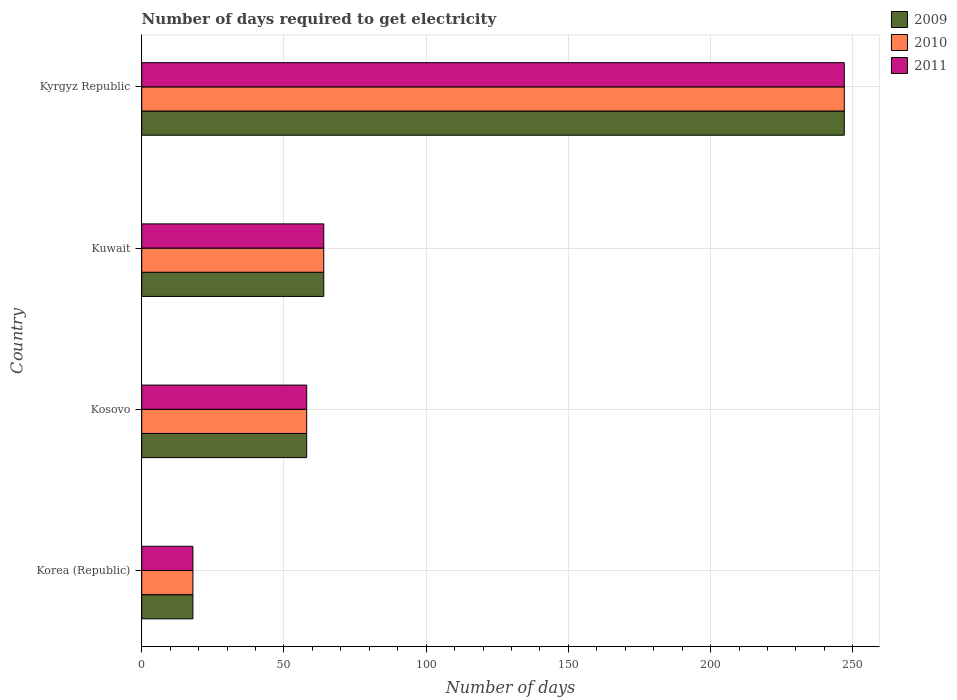Are the number of bars on each tick of the Y-axis equal?
Provide a short and direct response. Yes. How many bars are there on the 2nd tick from the top?
Provide a short and direct response. 3. How many bars are there on the 3rd tick from the bottom?
Offer a terse response. 3. What is the number of days required to get electricity in in 2010 in Kyrgyz Republic?
Offer a terse response. 247. Across all countries, what is the maximum number of days required to get electricity in in 2011?
Make the answer very short. 247. Across all countries, what is the minimum number of days required to get electricity in in 2009?
Keep it short and to the point. 18. In which country was the number of days required to get electricity in in 2009 maximum?
Keep it short and to the point. Kyrgyz Republic. In which country was the number of days required to get electricity in in 2011 minimum?
Keep it short and to the point. Korea (Republic). What is the total number of days required to get electricity in in 2009 in the graph?
Offer a very short reply. 387. What is the difference between the number of days required to get electricity in in 2009 in Korea (Republic) and that in Kyrgyz Republic?
Offer a very short reply. -229. What is the difference between the number of days required to get electricity in in 2010 in Kosovo and the number of days required to get electricity in in 2009 in Kyrgyz Republic?
Provide a short and direct response. -189. What is the average number of days required to get electricity in in 2011 per country?
Provide a short and direct response. 96.75. What is the difference between the number of days required to get electricity in in 2011 and number of days required to get electricity in in 2009 in Korea (Republic)?
Your response must be concise. 0. In how many countries, is the number of days required to get electricity in in 2011 greater than 190 days?
Offer a very short reply. 1. What is the ratio of the number of days required to get electricity in in 2010 in Korea (Republic) to that in Kuwait?
Provide a short and direct response. 0.28. Is the number of days required to get electricity in in 2011 in Kuwait less than that in Kyrgyz Republic?
Offer a very short reply. Yes. What is the difference between the highest and the second highest number of days required to get electricity in in 2010?
Offer a terse response. 183. What is the difference between the highest and the lowest number of days required to get electricity in in 2010?
Your answer should be compact. 229. Is it the case that in every country, the sum of the number of days required to get electricity in in 2011 and number of days required to get electricity in in 2010 is greater than the number of days required to get electricity in in 2009?
Offer a terse response. Yes. How many bars are there?
Your answer should be compact. 12. Are all the bars in the graph horizontal?
Ensure brevity in your answer.  Yes. How many countries are there in the graph?
Provide a short and direct response. 4. Where does the legend appear in the graph?
Ensure brevity in your answer.  Top right. How many legend labels are there?
Provide a succinct answer. 3. How are the legend labels stacked?
Your answer should be compact. Vertical. What is the title of the graph?
Offer a terse response. Number of days required to get electricity. Does "1989" appear as one of the legend labels in the graph?
Offer a very short reply. No. What is the label or title of the X-axis?
Provide a succinct answer. Number of days. What is the label or title of the Y-axis?
Offer a terse response. Country. What is the Number of days of 2009 in Korea (Republic)?
Keep it short and to the point. 18. What is the Number of days of 2011 in Kosovo?
Your answer should be very brief. 58. What is the Number of days in 2009 in Kyrgyz Republic?
Provide a short and direct response. 247. What is the Number of days of 2010 in Kyrgyz Republic?
Keep it short and to the point. 247. What is the Number of days of 2011 in Kyrgyz Republic?
Give a very brief answer. 247. Across all countries, what is the maximum Number of days of 2009?
Make the answer very short. 247. Across all countries, what is the maximum Number of days in 2010?
Provide a succinct answer. 247. Across all countries, what is the maximum Number of days of 2011?
Ensure brevity in your answer.  247. Across all countries, what is the minimum Number of days of 2009?
Your answer should be compact. 18. Across all countries, what is the minimum Number of days in 2010?
Your answer should be very brief. 18. Across all countries, what is the minimum Number of days of 2011?
Keep it short and to the point. 18. What is the total Number of days in 2009 in the graph?
Keep it short and to the point. 387. What is the total Number of days in 2010 in the graph?
Your answer should be compact. 387. What is the total Number of days in 2011 in the graph?
Provide a succinct answer. 387. What is the difference between the Number of days of 2010 in Korea (Republic) and that in Kosovo?
Your response must be concise. -40. What is the difference between the Number of days of 2011 in Korea (Republic) and that in Kosovo?
Your answer should be very brief. -40. What is the difference between the Number of days of 2009 in Korea (Republic) and that in Kuwait?
Make the answer very short. -46. What is the difference between the Number of days of 2010 in Korea (Republic) and that in Kuwait?
Your response must be concise. -46. What is the difference between the Number of days in 2011 in Korea (Republic) and that in Kuwait?
Provide a succinct answer. -46. What is the difference between the Number of days in 2009 in Korea (Republic) and that in Kyrgyz Republic?
Your answer should be very brief. -229. What is the difference between the Number of days of 2010 in Korea (Republic) and that in Kyrgyz Republic?
Your answer should be compact. -229. What is the difference between the Number of days of 2011 in Korea (Republic) and that in Kyrgyz Republic?
Provide a short and direct response. -229. What is the difference between the Number of days in 2009 in Kosovo and that in Kuwait?
Provide a succinct answer. -6. What is the difference between the Number of days of 2011 in Kosovo and that in Kuwait?
Keep it short and to the point. -6. What is the difference between the Number of days of 2009 in Kosovo and that in Kyrgyz Republic?
Offer a very short reply. -189. What is the difference between the Number of days of 2010 in Kosovo and that in Kyrgyz Republic?
Your response must be concise. -189. What is the difference between the Number of days in 2011 in Kosovo and that in Kyrgyz Republic?
Your answer should be compact. -189. What is the difference between the Number of days of 2009 in Kuwait and that in Kyrgyz Republic?
Make the answer very short. -183. What is the difference between the Number of days of 2010 in Kuwait and that in Kyrgyz Republic?
Give a very brief answer. -183. What is the difference between the Number of days of 2011 in Kuwait and that in Kyrgyz Republic?
Ensure brevity in your answer.  -183. What is the difference between the Number of days of 2009 in Korea (Republic) and the Number of days of 2010 in Kosovo?
Your answer should be very brief. -40. What is the difference between the Number of days in 2010 in Korea (Republic) and the Number of days in 2011 in Kosovo?
Offer a terse response. -40. What is the difference between the Number of days in 2009 in Korea (Republic) and the Number of days in 2010 in Kuwait?
Provide a succinct answer. -46. What is the difference between the Number of days of 2009 in Korea (Republic) and the Number of days of 2011 in Kuwait?
Give a very brief answer. -46. What is the difference between the Number of days in 2010 in Korea (Republic) and the Number of days in 2011 in Kuwait?
Give a very brief answer. -46. What is the difference between the Number of days of 2009 in Korea (Republic) and the Number of days of 2010 in Kyrgyz Republic?
Ensure brevity in your answer.  -229. What is the difference between the Number of days in 2009 in Korea (Republic) and the Number of days in 2011 in Kyrgyz Republic?
Your answer should be very brief. -229. What is the difference between the Number of days of 2010 in Korea (Republic) and the Number of days of 2011 in Kyrgyz Republic?
Your answer should be very brief. -229. What is the difference between the Number of days in 2009 in Kosovo and the Number of days in 2010 in Kyrgyz Republic?
Ensure brevity in your answer.  -189. What is the difference between the Number of days of 2009 in Kosovo and the Number of days of 2011 in Kyrgyz Republic?
Provide a succinct answer. -189. What is the difference between the Number of days in 2010 in Kosovo and the Number of days in 2011 in Kyrgyz Republic?
Provide a succinct answer. -189. What is the difference between the Number of days of 2009 in Kuwait and the Number of days of 2010 in Kyrgyz Republic?
Your response must be concise. -183. What is the difference between the Number of days in 2009 in Kuwait and the Number of days in 2011 in Kyrgyz Republic?
Offer a very short reply. -183. What is the difference between the Number of days in 2010 in Kuwait and the Number of days in 2011 in Kyrgyz Republic?
Provide a succinct answer. -183. What is the average Number of days of 2009 per country?
Your answer should be very brief. 96.75. What is the average Number of days of 2010 per country?
Your answer should be compact. 96.75. What is the average Number of days of 2011 per country?
Your answer should be compact. 96.75. What is the difference between the Number of days in 2010 and Number of days in 2011 in Korea (Republic)?
Provide a succinct answer. 0. What is the difference between the Number of days in 2009 and Number of days in 2010 in Kosovo?
Provide a short and direct response. 0. What is the difference between the Number of days in 2010 and Number of days in 2011 in Kosovo?
Provide a succinct answer. 0. What is the difference between the Number of days of 2009 and Number of days of 2010 in Kuwait?
Provide a succinct answer. 0. What is the difference between the Number of days in 2009 and Number of days in 2011 in Kuwait?
Keep it short and to the point. 0. What is the difference between the Number of days in 2009 and Number of days in 2011 in Kyrgyz Republic?
Offer a very short reply. 0. What is the ratio of the Number of days of 2009 in Korea (Republic) to that in Kosovo?
Provide a short and direct response. 0.31. What is the ratio of the Number of days in 2010 in Korea (Republic) to that in Kosovo?
Your answer should be compact. 0.31. What is the ratio of the Number of days in 2011 in Korea (Republic) to that in Kosovo?
Make the answer very short. 0.31. What is the ratio of the Number of days of 2009 in Korea (Republic) to that in Kuwait?
Ensure brevity in your answer.  0.28. What is the ratio of the Number of days of 2010 in Korea (Republic) to that in Kuwait?
Ensure brevity in your answer.  0.28. What is the ratio of the Number of days of 2011 in Korea (Republic) to that in Kuwait?
Give a very brief answer. 0.28. What is the ratio of the Number of days of 2009 in Korea (Republic) to that in Kyrgyz Republic?
Your response must be concise. 0.07. What is the ratio of the Number of days in 2010 in Korea (Republic) to that in Kyrgyz Republic?
Your response must be concise. 0.07. What is the ratio of the Number of days of 2011 in Korea (Republic) to that in Kyrgyz Republic?
Your answer should be compact. 0.07. What is the ratio of the Number of days in 2009 in Kosovo to that in Kuwait?
Your response must be concise. 0.91. What is the ratio of the Number of days in 2010 in Kosovo to that in Kuwait?
Give a very brief answer. 0.91. What is the ratio of the Number of days of 2011 in Kosovo to that in Kuwait?
Your answer should be very brief. 0.91. What is the ratio of the Number of days of 2009 in Kosovo to that in Kyrgyz Republic?
Provide a short and direct response. 0.23. What is the ratio of the Number of days in 2010 in Kosovo to that in Kyrgyz Republic?
Provide a succinct answer. 0.23. What is the ratio of the Number of days of 2011 in Kosovo to that in Kyrgyz Republic?
Offer a terse response. 0.23. What is the ratio of the Number of days of 2009 in Kuwait to that in Kyrgyz Republic?
Your answer should be very brief. 0.26. What is the ratio of the Number of days of 2010 in Kuwait to that in Kyrgyz Republic?
Keep it short and to the point. 0.26. What is the ratio of the Number of days in 2011 in Kuwait to that in Kyrgyz Republic?
Ensure brevity in your answer.  0.26. What is the difference between the highest and the second highest Number of days in 2009?
Your response must be concise. 183. What is the difference between the highest and the second highest Number of days of 2010?
Offer a terse response. 183. What is the difference between the highest and the second highest Number of days in 2011?
Provide a short and direct response. 183. What is the difference between the highest and the lowest Number of days in 2009?
Ensure brevity in your answer.  229. What is the difference between the highest and the lowest Number of days in 2010?
Your response must be concise. 229. What is the difference between the highest and the lowest Number of days in 2011?
Your answer should be compact. 229. 